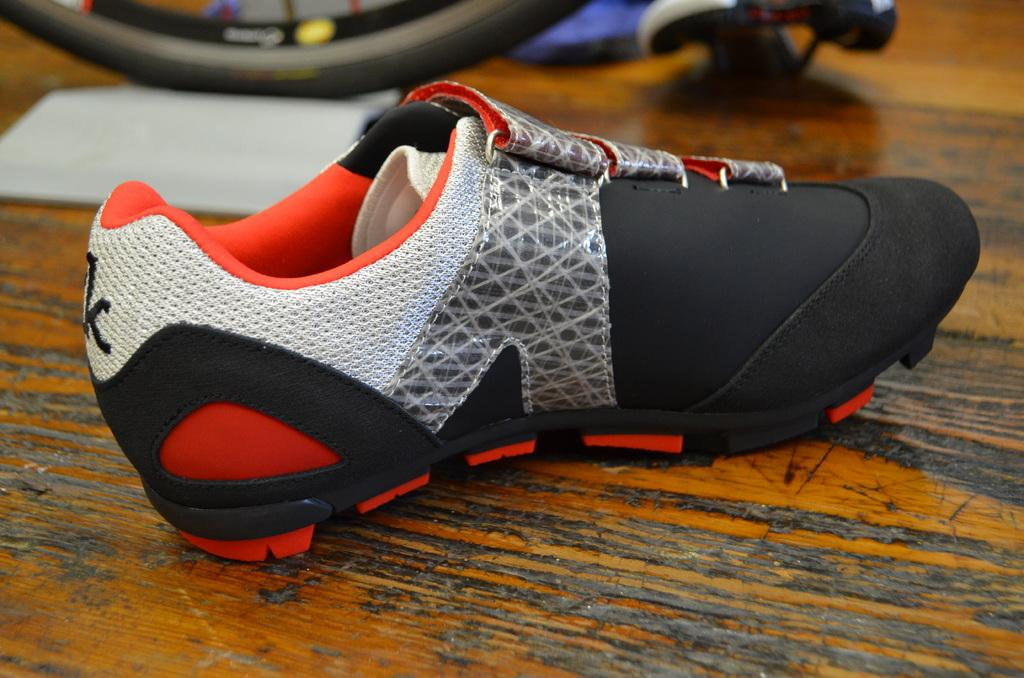What object is placed on the floor in the image? There is a shoe on the floor in the image. What type of wheel can be seen in the image? There is a bicycle wheel visible in the image. Can you describe the appearance of some objects in the image? There are blurred objects in the image. What type of bear can be seen interacting with the paste in the image? There is no bear or paste present in the image. How does the form of the shoe change throughout the image? The form of the shoe does not change throughout the image; it remains a single, stationary object. 